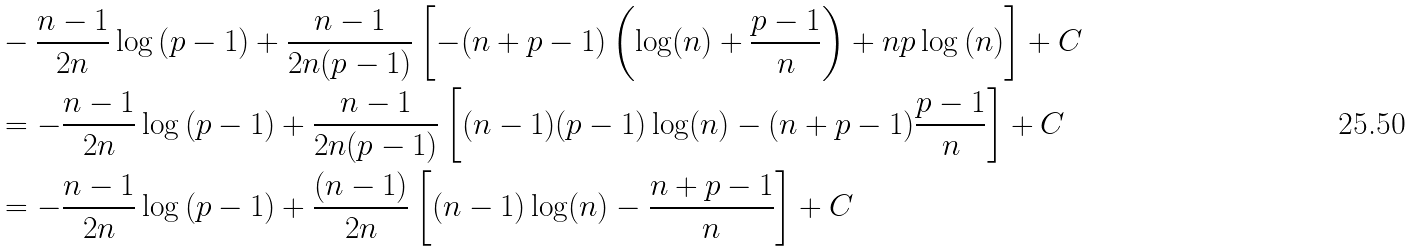Convert formula to latex. <formula><loc_0><loc_0><loc_500><loc_500>& - \frac { n - 1 } { 2 n } \log \left ( p - 1 \right ) + \frac { n - 1 } { 2 n ( p - 1 ) } \left [ - ( n + p - 1 ) \left ( \log ( n ) + \frac { p - 1 } { n } \right ) + n p \log \left ( n \right ) \right ] + C \\ & = - \frac { n - 1 } { 2 n } \log \left ( p - 1 \right ) + \frac { n - 1 } { 2 n ( p - 1 ) } \left [ ( n - 1 ) ( p - 1 ) \log ( n ) - ( n + p - 1 ) \frac { p - 1 } { n } \right ] + C \\ & = - \frac { n - 1 } { 2 n } \log \left ( p - 1 \right ) + \frac { ( n - 1 ) } { 2 n } \left [ ( n - 1 ) \log ( n ) - \frac { n + p - 1 } { n } \right ] + C</formula> 